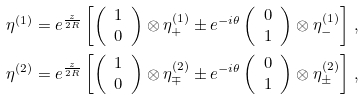Convert formula to latex. <formula><loc_0><loc_0><loc_500><loc_500>\eta ^ { ( 1 ) } & = e ^ { \frac { z } { 2 R } } \left [ \left ( \begin{array} { c } 1 \\ 0 \end{array} \right ) \otimes \eta ^ { ( 1 ) } _ { + } \pm e ^ { - i \theta } \left ( \begin{array} { c } 0 \\ 1 \end{array} \right ) \otimes \eta ^ { ( 1 ) } _ { - } \right ] \, , \\ \eta ^ { ( 2 ) } & = e ^ { \frac { z } { 2 R } } \left [ \left ( \begin{array} { c } 1 \\ 0 \end{array} \right ) \otimes \eta ^ { ( 2 ) } _ { \mp } \pm e ^ { - i \theta } \left ( \begin{array} { c } 0 \\ 1 \end{array} \right ) \otimes \eta ^ { ( 2 ) } _ { \pm } \right ] \, ,</formula> 